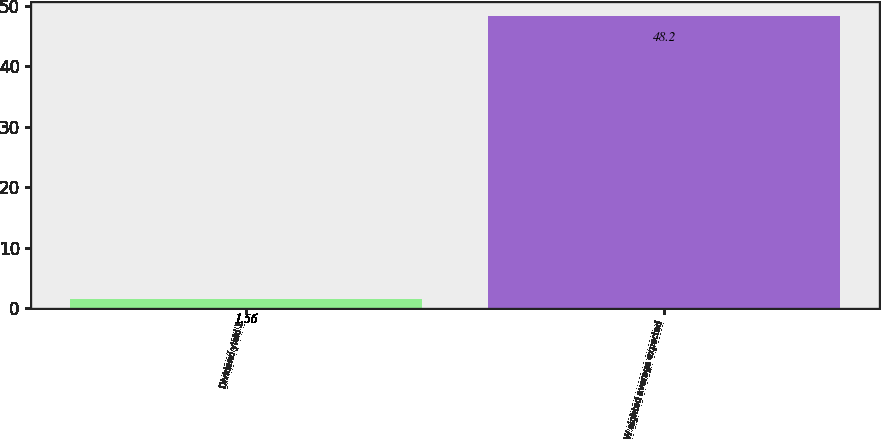Convert chart. <chart><loc_0><loc_0><loc_500><loc_500><bar_chart><fcel>Dividend yield 1<fcel>W eighted average expected<nl><fcel>1.56<fcel>48.2<nl></chart> 